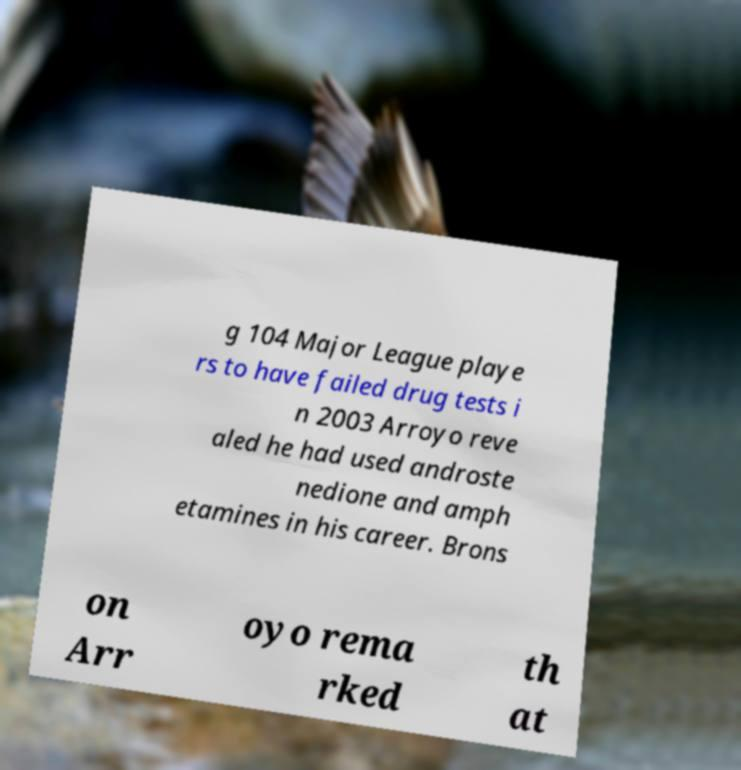Could you assist in decoding the text presented in this image and type it out clearly? g 104 Major League playe rs to have failed drug tests i n 2003 Arroyo reve aled he had used androste nedione and amph etamines in his career. Brons on Arr oyo rema rked th at 